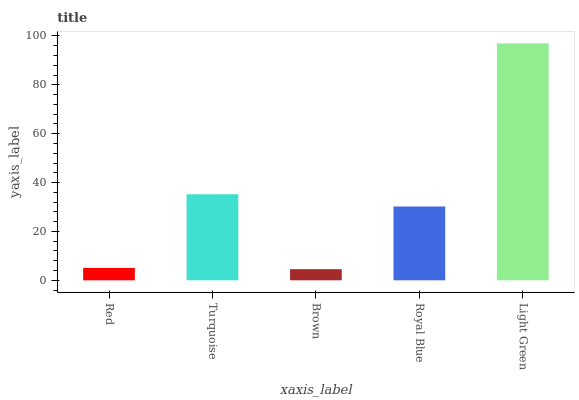Is Brown the minimum?
Answer yes or no. Yes. Is Light Green the maximum?
Answer yes or no. Yes. Is Turquoise the minimum?
Answer yes or no. No. Is Turquoise the maximum?
Answer yes or no. No. Is Turquoise greater than Red?
Answer yes or no. Yes. Is Red less than Turquoise?
Answer yes or no. Yes. Is Red greater than Turquoise?
Answer yes or no. No. Is Turquoise less than Red?
Answer yes or no. No. Is Royal Blue the high median?
Answer yes or no. Yes. Is Royal Blue the low median?
Answer yes or no. Yes. Is Light Green the high median?
Answer yes or no. No. Is Brown the low median?
Answer yes or no. No. 